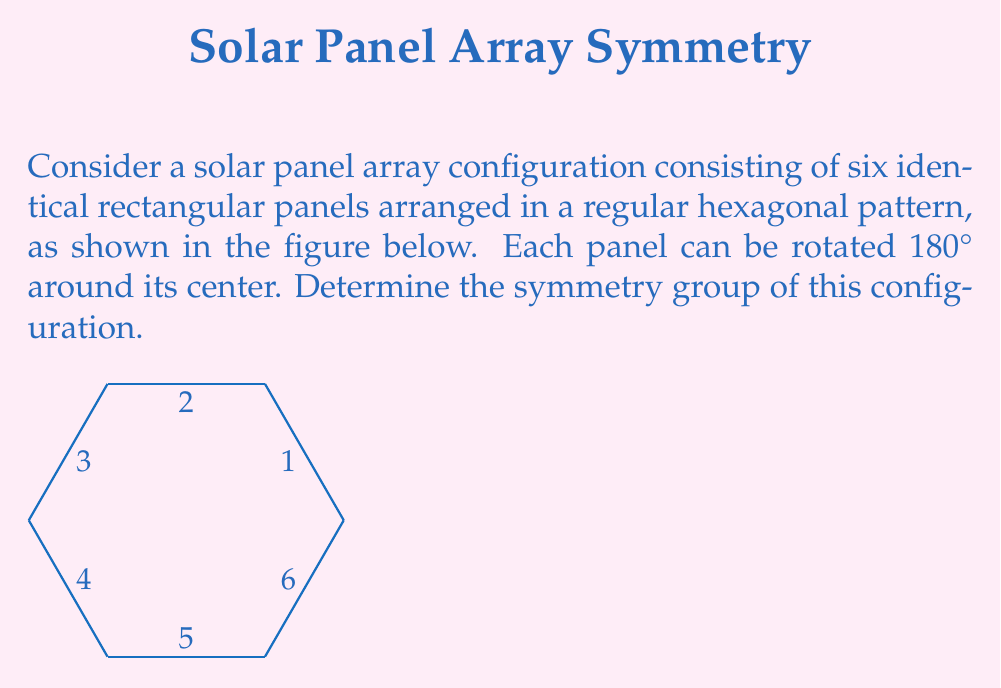Can you solve this math problem? To determine the symmetry group of this solar panel array, we need to identify all the symmetry operations that leave the configuration unchanged. Let's approach this step-by-step:

1) Rotational symmetries:
   - The array has 6-fold rotational symmetry (rotations by multiples of 60°).
   - Each panel has 2-fold rotational symmetry (180° rotation).

2) Reflection symmetries:
   - There are 6 lines of reflection (through the center and each vertex, and through the center and the midpoint of each side).

3) Identity operation:
   - The identity operation (doing nothing) is always a symmetry.

4) Combining these symmetries:
   - 6 rotations (including identity): $e, r, r^2, r^3, r^4, r^5$ where $r$ is a 60° rotation.
   - 6 reflections: $s_1, s_2, s_3, s_4, s_5, s_6$
   - 6 rotoreflections: $rs_1, r^2s_1, r^3s_1, r^4s_1, r^5s_1, r^6s_1$

5) Total number of symmetries: 6 + 6 + 6 = 18

6) Group structure:
   This group is isomorphic to $D_6 \times C_2$, where:
   - $D_6$ is the dihedral group of order 12 (symmetries of a regular hexagon)
   - $C_2$ is the cyclic group of order 2 (180° rotation of individual panels)

The direct product $\times$ arises because each symmetry of the hexagonal arrangement can be combined with either keeping the panels as they are or flipping all of them.
Answer: $D_6 \times C_2$ 